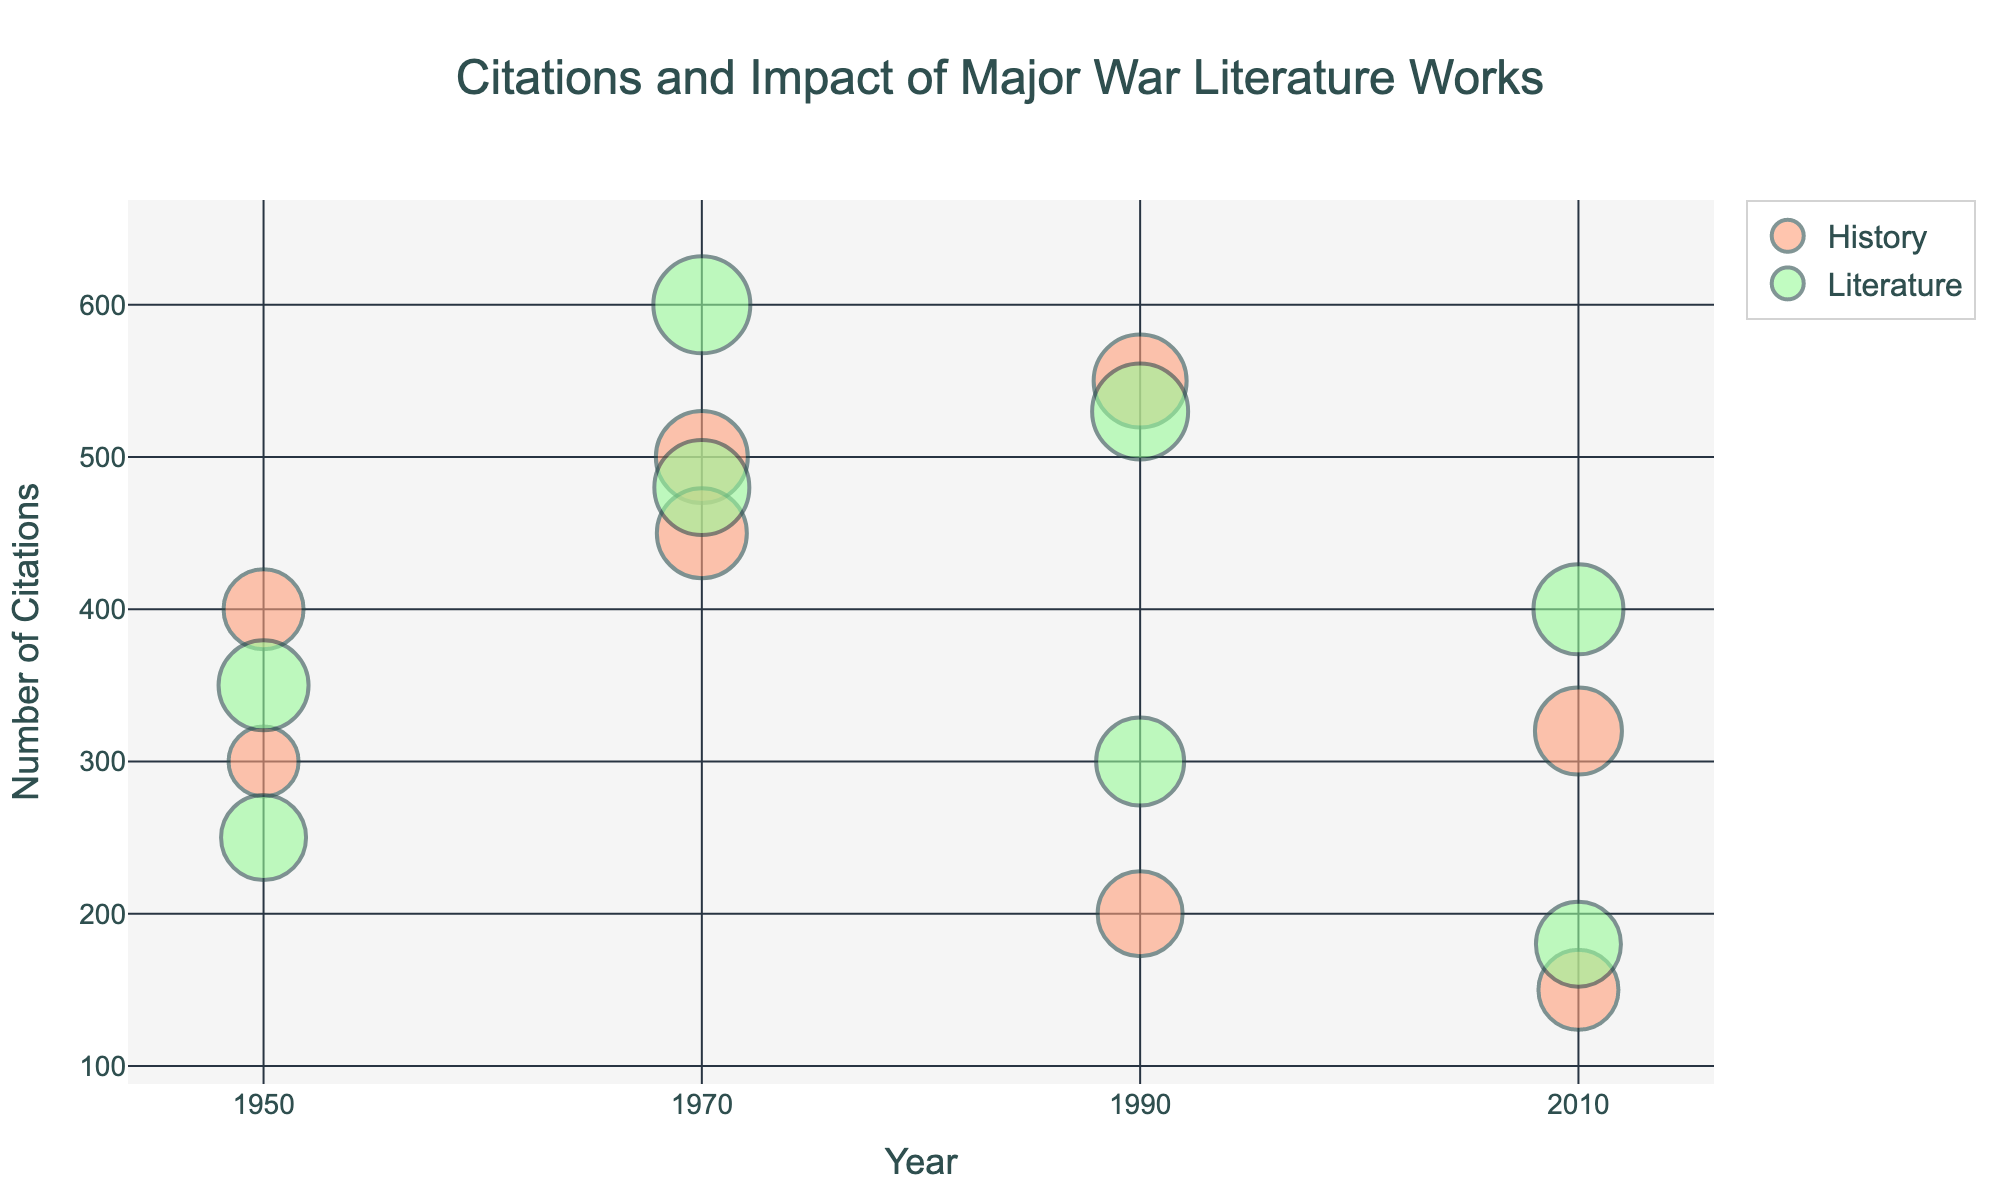When were the citations for "All Quiet on the Western Front" in the field of History highest? The figure shows bubbles representing different works and academic fields over the decades. By locating the bubble for "All Quiet on the Western Front" under the History category and checking the Year axis, we determine that it was in 1950.
Answer: 1950 How many citations did "Slaughterhouse-Five" receive in the field of Literature in 1970? Find the bubble for "Slaughterhouse-Five" under the Literature category for the year 1970. The label on the bubble shows the number of citations.
Answer: 600 Which war literature work had the lowest number of citations in History in 2010? By examining the bubbles under History for the year 2010 and comparing their sizes, we find that "Redeployment" has the smallest bubble, indicating the lowest citations.
Answer: Redeployment Compare the impact of "Maus" in History and Literature in 1990. Which field had a higher impact? Compare the sizes of the bubbles for "Maus" in both History and Literature for the year 1990. The Literature bubble is larger, indicating a higher impact.
Answer: Literature What is the total number of citations for war literature works in the field of Literature in 1950? Sum the citations for "All Quiet on the Western Front" and "The Red Badge of Courage" in 1950 under Literature. 350 + 250 = 600
Answer: 600 How does the number of citations for "Catch-22" compare between History and Literature in 1970? Compare the bubbles for "Catch-22" under both History and Literature in 1970. The Literature bubble reports higher citations.
Answer: Literature has more What is the average impact of the war literature works cited in 1990 in the field of History? Add the impact values for History works in 1990 and divide by the number of works: (0.93 + 0.85) / 2 = 0.89
Answer: 0.89 How many works were cited in both History and Literature in 2010, and what are their titles? Look for bubbles in both fields for the year 2010. The shared titles are "The Book Thief" and "Redeployment."
Answer: 2, "The Book Thief" and "Redeployment" Which decade saw the highest citations for "Slaughterhouse-Five"? Find the bubbles for "Slaughterhouse-Five" and compare the size labels across different decades. The largest citation count is in 1970.
Answer: 1970 Which field had the higher average impact in 1990, History or Literature? Calculate the average impact for both fields: History (0.93 + 0.85) / 2 = 0.89, Literature (0.96 + 0.88) / 2 = 0.92. Literature has a higher average impact.
Answer: Literature 